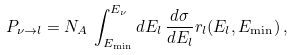<formula> <loc_0><loc_0><loc_500><loc_500>P _ { \nu \rightarrow l } = N _ { A } \, \int _ { E _ { \min } } ^ { E _ { \nu } } d E _ { l } \, \frac { d \sigma } { d E _ { l } } r _ { l } ( E _ { l } , E _ { \min } ) \, ,</formula> 